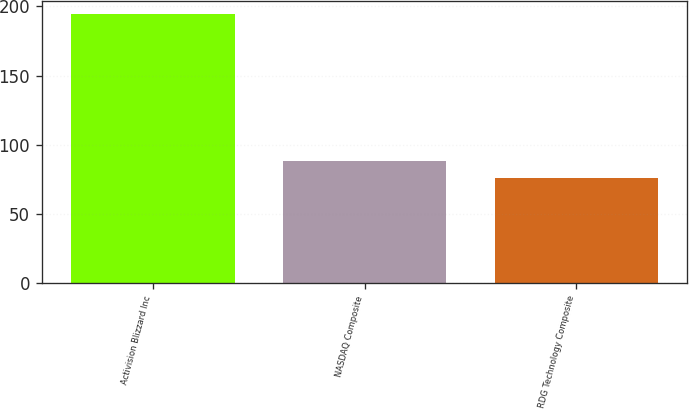Convert chart. <chart><loc_0><loc_0><loc_500><loc_500><bar_chart><fcel>Activision Blizzard Inc<fcel>NASDAQ Composite<fcel>RDG Technology Composite<nl><fcel>194.18<fcel>87.86<fcel>76.05<nl></chart> 